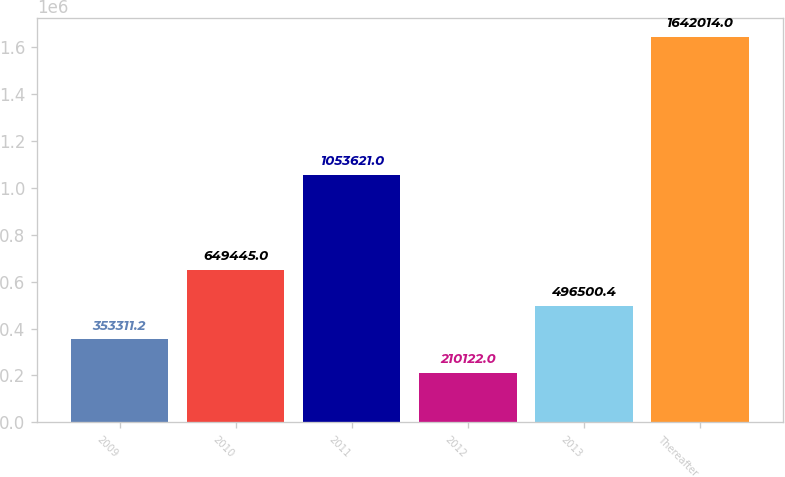Convert chart to OTSL. <chart><loc_0><loc_0><loc_500><loc_500><bar_chart><fcel>2009<fcel>2010<fcel>2011<fcel>2012<fcel>2013<fcel>Thereafter<nl><fcel>353311<fcel>649445<fcel>1.05362e+06<fcel>210122<fcel>496500<fcel>1.64201e+06<nl></chart> 